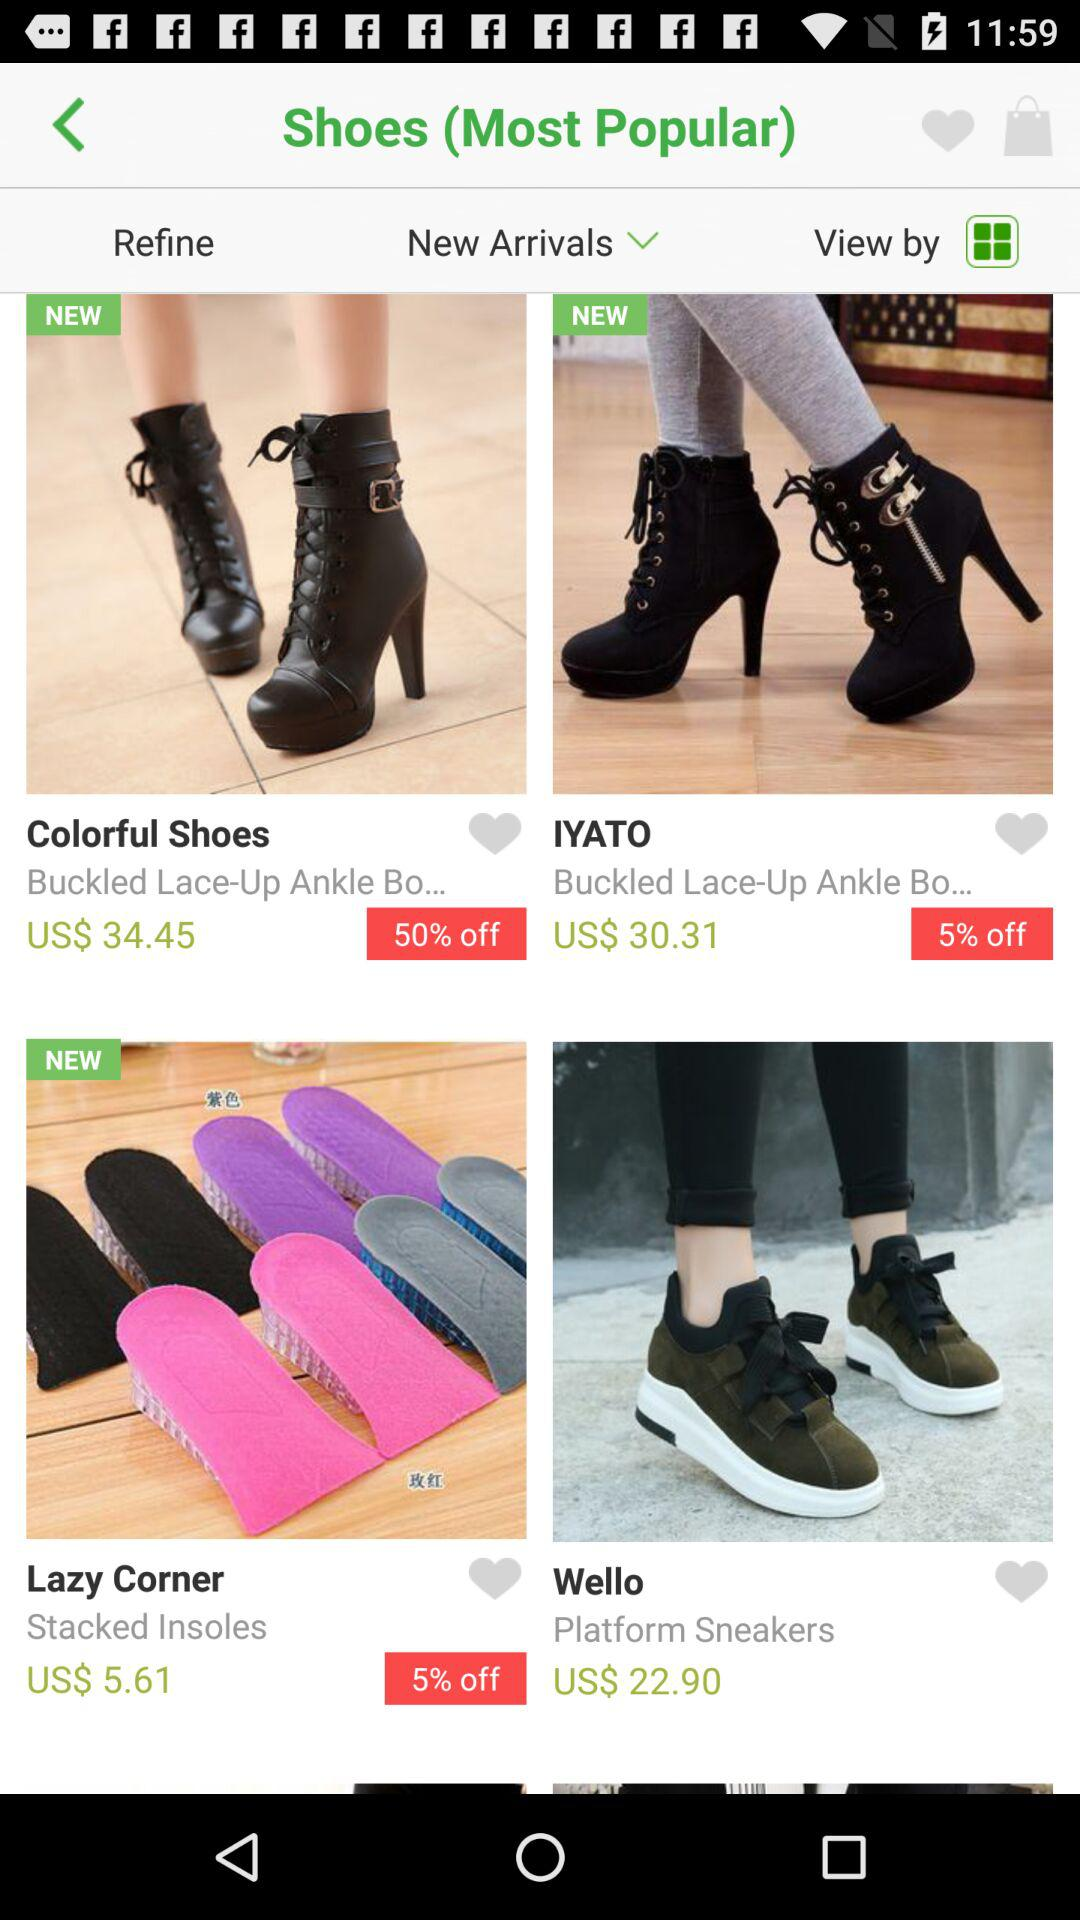What is the price of the "Wello"? The price is US$ 22.90. 